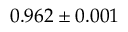Convert formula to latex. <formula><loc_0><loc_0><loc_500><loc_500>0 . 9 6 2 \pm 0 . 0 0 1</formula> 